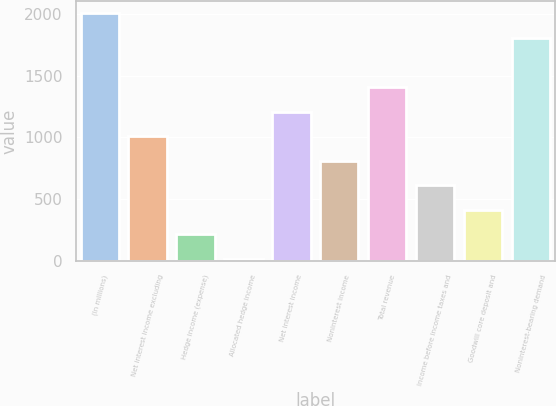<chart> <loc_0><loc_0><loc_500><loc_500><bar_chart><fcel>(In millions)<fcel>Net interest income excluding<fcel>Hedge income (expense)<fcel>Allocated hedge income<fcel>Net interest income<fcel>Noninterest income<fcel>Total revenue<fcel>Income before income taxes and<fcel>Goodwill core deposit and<fcel>Noninterest-bearing demand<nl><fcel>2004<fcel>1009.7<fcel>214.26<fcel>15.4<fcel>1208.56<fcel>810.84<fcel>1407.42<fcel>611.98<fcel>413.12<fcel>1805.14<nl></chart> 